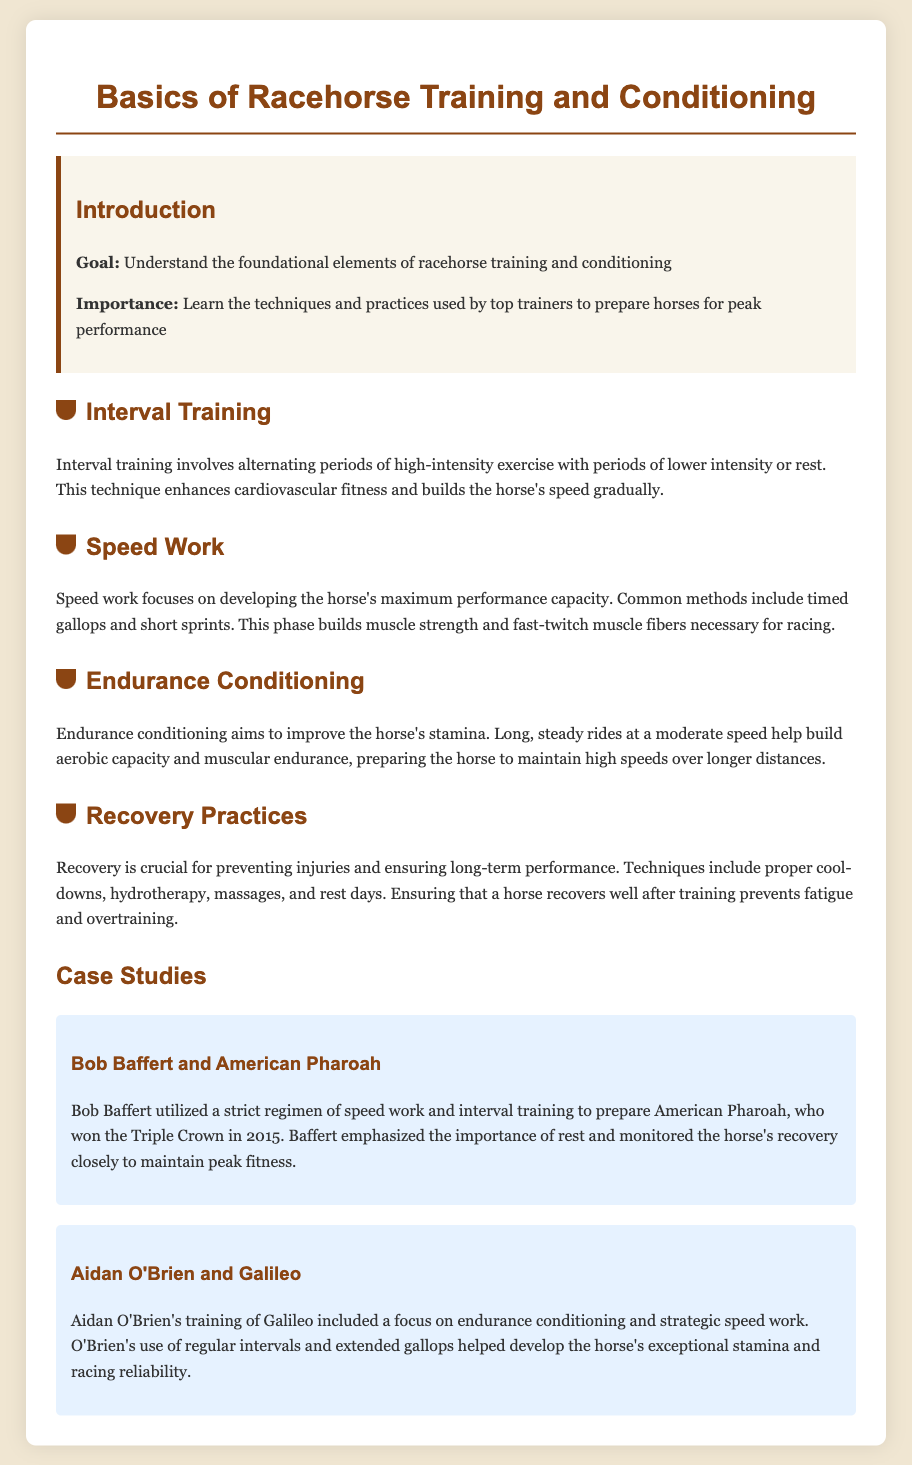What is the goal of the lesson plan? The goal is stated clearly in the introduction section as understanding the foundational elements of racehorse training and conditioning.
Answer: Understand the foundational elements of racehorse training and conditioning What technique enhances cardiovascular fitness in racehorses? The document states that interval training enhances cardiovascular fitness and builds the horse's speed gradually.
Answer: Interval training Who trained American Pharoah? The case study mentions that Bob Baffert was the trainer of American Pharoah.
Answer: Bob Baffert What is the primary focus of speed work? The document describes speed work as focusing on developing the horse's maximum performance capacity.
Answer: Maximum performance capacity Which trainer focused on endurance conditioning for Galileo? Aidan O'Brien is mentioned as the trainer who focused on endurance conditioning for Galileo.
Answer: Aidan O'Brien How does recovery contribute to long-term performance? The document highlights that recovery practices are crucial for preventing injuries and ensuring long-term performance.
Answer: Preventing injuries and ensuring long-term performance What year did American Pharoah win the Triple Crown? The case study states that American Pharoah won the Triple Crown in 2015.
Answer: 2015 What is one technique mentioned for recovery practices? The document lists proper cool-downs as one of the recovery techniques.
Answer: Proper cool-downs 